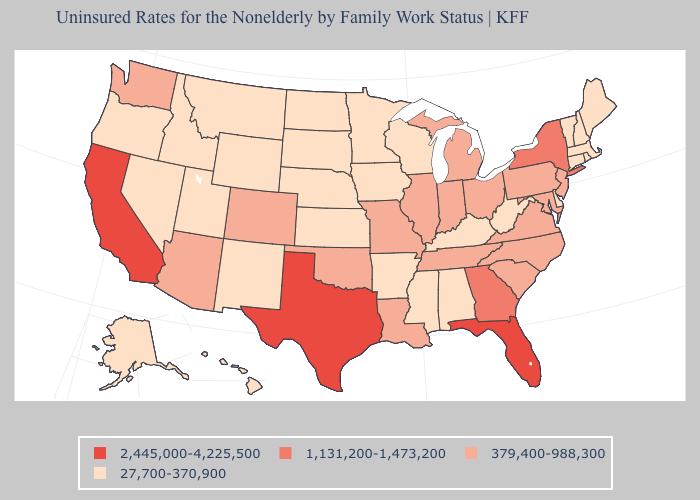Which states have the highest value in the USA?
Keep it brief. California, Florida, Texas. Which states have the highest value in the USA?
Keep it brief. California, Florida, Texas. Which states have the lowest value in the West?
Quick response, please. Alaska, Hawaii, Idaho, Montana, Nevada, New Mexico, Oregon, Utah, Wyoming. Which states hav the highest value in the West?
Be succinct. California. What is the lowest value in states that border South Carolina?
Quick response, please. 379,400-988,300. Name the states that have a value in the range 2,445,000-4,225,500?
Answer briefly. California, Florida, Texas. Does Mississippi have a lower value than Michigan?
Answer briefly. Yes. Does South Carolina have the same value as Alabama?
Quick response, please. No. How many symbols are there in the legend?
Short answer required. 4. Does Florida have a higher value than Connecticut?
Be succinct. Yes. What is the value of Arkansas?
Answer briefly. 27,700-370,900. What is the value of Arkansas?
Write a very short answer. 27,700-370,900. What is the value of West Virginia?
Give a very brief answer. 27,700-370,900. What is the value of Rhode Island?
Short answer required. 27,700-370,900. How many symbols are there in the legend?
Give a very brief answer. 4. 